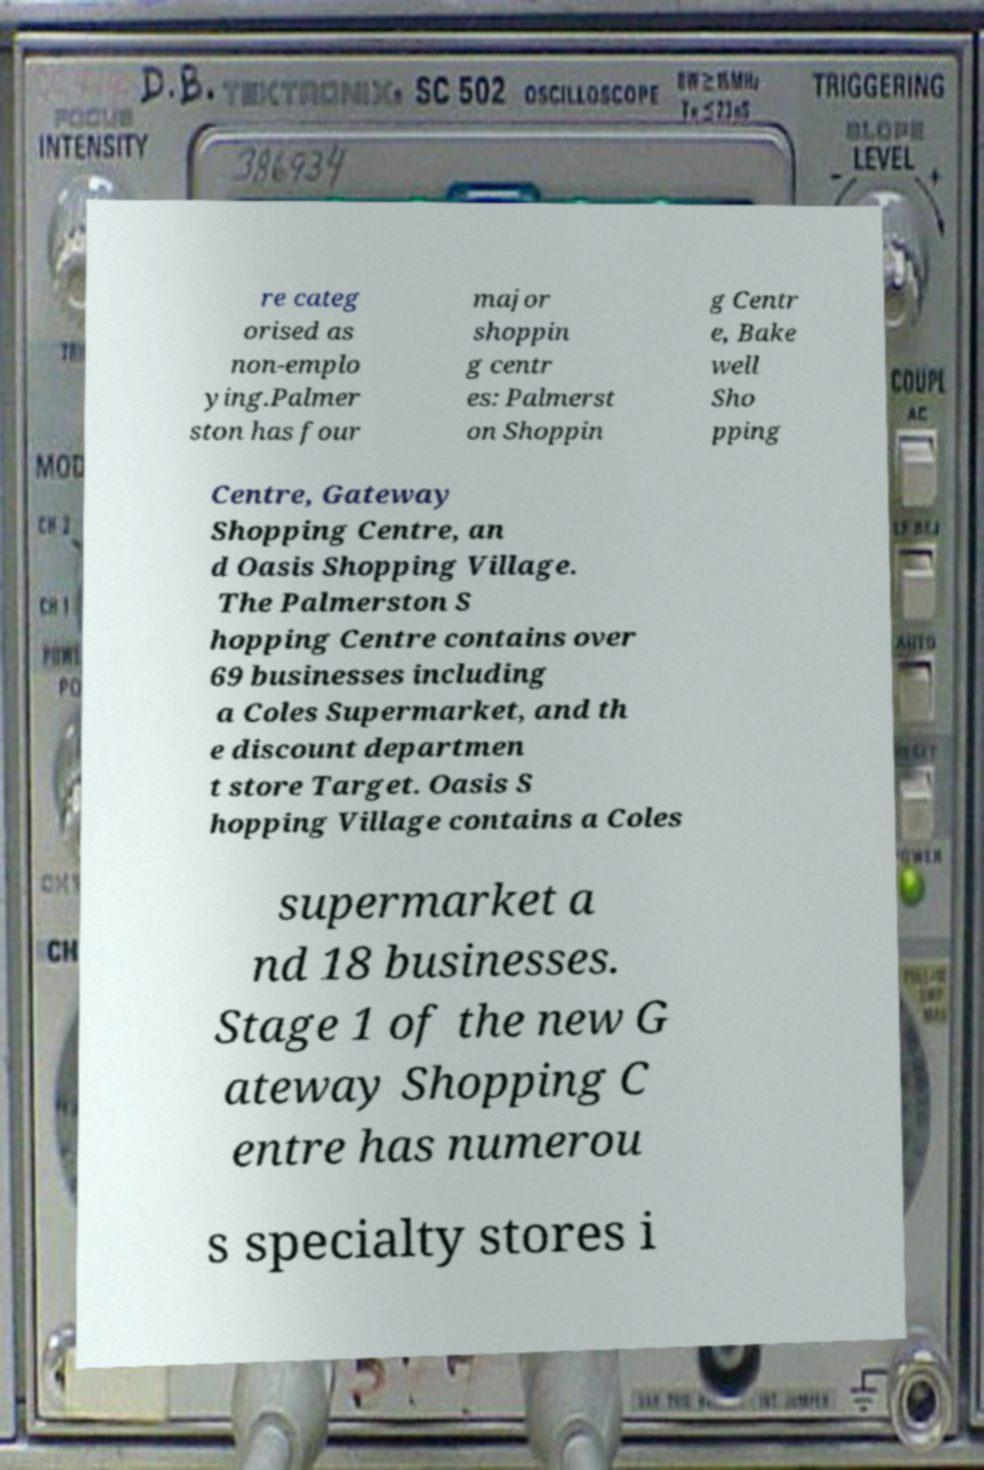Could you extract and type out the text from this image? re categ orised as non-emplo ying.Palmer ston has four major shoppin g centr es: Palmerst on Shoppin g Centr e, Bake well Sho pping Centre, Gateway Shopping Centre, an d Oasis Shopping Village. The Palmerston S hopping Centre contains over 69 businesses including a Coles Supermarket, and th e discount departmen t store Target. Oasis S hopping Village contains a Coles supermarket a nd 18 businesses. Stage 1 of the new G ateway Shopping C entre has numerou s specialty stores i 